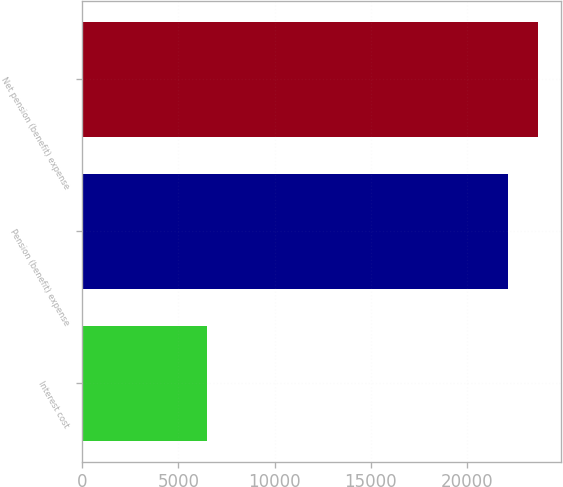<chart> <loc_0><loc_0><loc_500><loc_500><bar_chart><fcel>Interest cost<fcel>Pension (benefit) expense<fcel>Net pension (benefit) expense<nl><fcel>6464<fcel>22129<fcel>23695.5<nl></chart> 